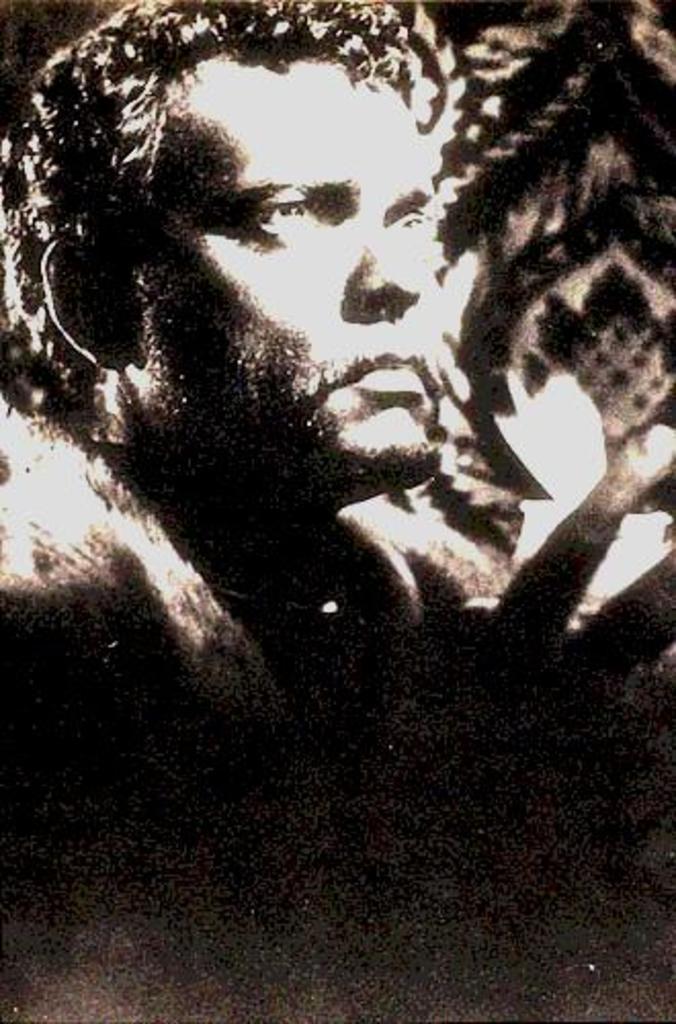Can you describe this image briefly? This is a black and white image. In this image we can see a man. 